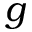<formula> <loc_0><loc_0><loc_500><loc_500>g</formula> 